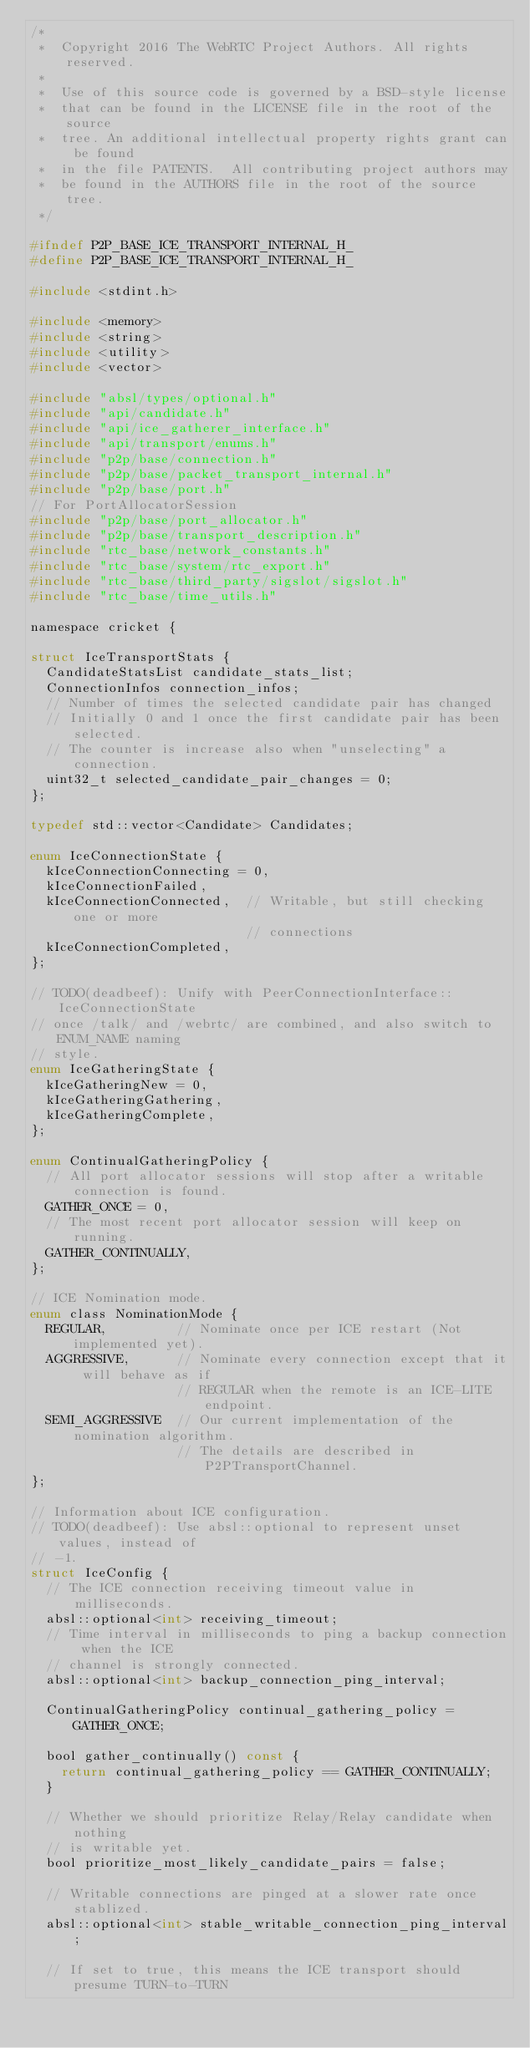Convert code to text. <code><loc_0><loc_0><loc_500><loc_500><_C_>/*
 *  Copyright 2016 The WebRTC Project Authors. All rights reserved.
 *
 *  Use of this source code is governed by a BSD-style license
 *  that can be found in the LICENSE file in the root of the source
 *  tree. An additional intellectual property rights grant can be found
 *  in the file PATENTS.  All contributing project authors may
 *  be found in the AUTHORS file in the root of the source tree.
 */

#ifndef P2P_BASE_ICE_TRANSPORT_INTERNAL_H_
#define P2P_BASE_ICE_TRANSPORT_INTERNAL_H_

#include <stdint.h>

#include <memory>
#include <string>
#include <utility>
#include <vector>

#include "absl/types/optional.h"
#include "api/candidate.h"
#include "api/ice_gatherer_interface.h"
#include "api/transport/enums.h"
#include "p2p/base/connection.h"
#include "p2p/base/packet_transport_internal.h"
#include "p2p/base/port.h"
// For PortAllocatorSession
#include "p2p/base/port_allocator.h"
#include "p2p/base/transport_description.h"
#include "rtc_base/network_constants.h"
#include "rtc_base/system/rtc_export.h"
#include "rtc_base/third_party/sigslot/sigslot.h"
#include "rtc_base/time_utils.h"

namespace cricket {

struct IceTransportStats {
  CandidateStatsList candidate_stats_list;
  ConnectionInfos connection_infos;
  // Number of times the selected candidate pair has changed
  // Initially 0 and 1 once the first candidate pair has been selected.
  // The counter is increase also when "unselecting" a connection.
  uint32_t selected_candidate_pair_changes = 0;
};

typedef std::vector<Candidate> Candidates;

enum IceConnectionState {
  kIceConnectionConnecting = 0,
  kIceConnectionFailed,
  kIceConnectionConnected,  // Writable, but still checking one or more
                            // connections
  kIceConnectionCompleted,
};

// TODO(deadbeef): Unify with PeerConnectionInterface::IceConnectionState
// once /talk/ and /webrtc/ are combined, and also switch to ENUM_NAME naming
// style.
enum IceGatheringState {
  kIceGatheringNew = 0,
  kIceGatheringGathering,
  kIceGatheringComplete,
};

enum ContinualGatheringPolicy {
  // All port allocator sessions will stop after a writable connection is found.
  GATHER_ONCE = 0,
  // The most recent port allocator session will keep on running.
  GATHER_CONTINUALLY,
};

// ICE Nomination mode.
enum class NominationMode {
  REGULAR,         // Nominate once per ICE restart (Not implemented yet).
  AGGRESSIVE,      // Nominate every connection except that it will behave as if
                   // REGULAR when the remote is an ICE-LITE endpoint.
  SEMI_AGGRESSIVE  // Our current implementation of the nomination algorithm.
                   // The details are described in P2PTransportChannel.
};

// Information about ICE configuration.
// TODO(deadbeef): Use absl::optional to represent unset values, instead of
// -1.
struct IceConfig {
  // The ICE connection receiving timeout value in milliseconds.
  absl::optional<int> receiving_timeout;
  // Time interval in milliseconds to ping a backup connection when the ICE
  // channel is strongly connected.
  absl::optional<int> backup_connection_ping_interval;

  ContinualGatheringPolicy continual_gathering_policy = GATHER_ONCE;

  bool gather_continually() const {
    return continual_gathering_policy == GATHER_CONTINUALLY;
  }

  // Whether we should prioritize Relay/Relay candidate when nothing
  // is writable yet.
  bool prioritize_most_likely_candidate_pairs = false;

  // Writable connections are pinged at a slower rate once stablized.
  absl::optional<int> stable_writable_connection_ping_interval;

  // If set to true, this means the ICE transport should presume TURN-to-TURN</code> 